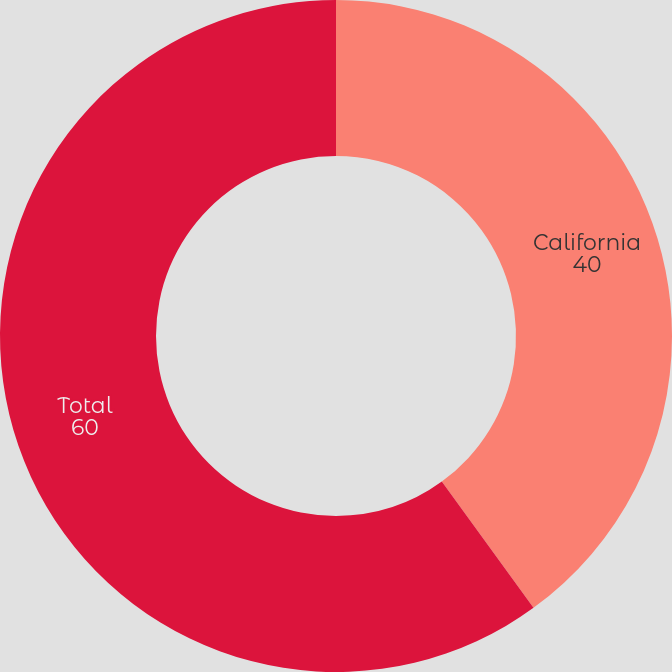Convert chart. <chart><loc_0><loc_0><loc_500><loc_500><pie_chart><fcel>California<fcel>Total<nl><fcel>40.0%<fcel>60.0%<nl></chart> 